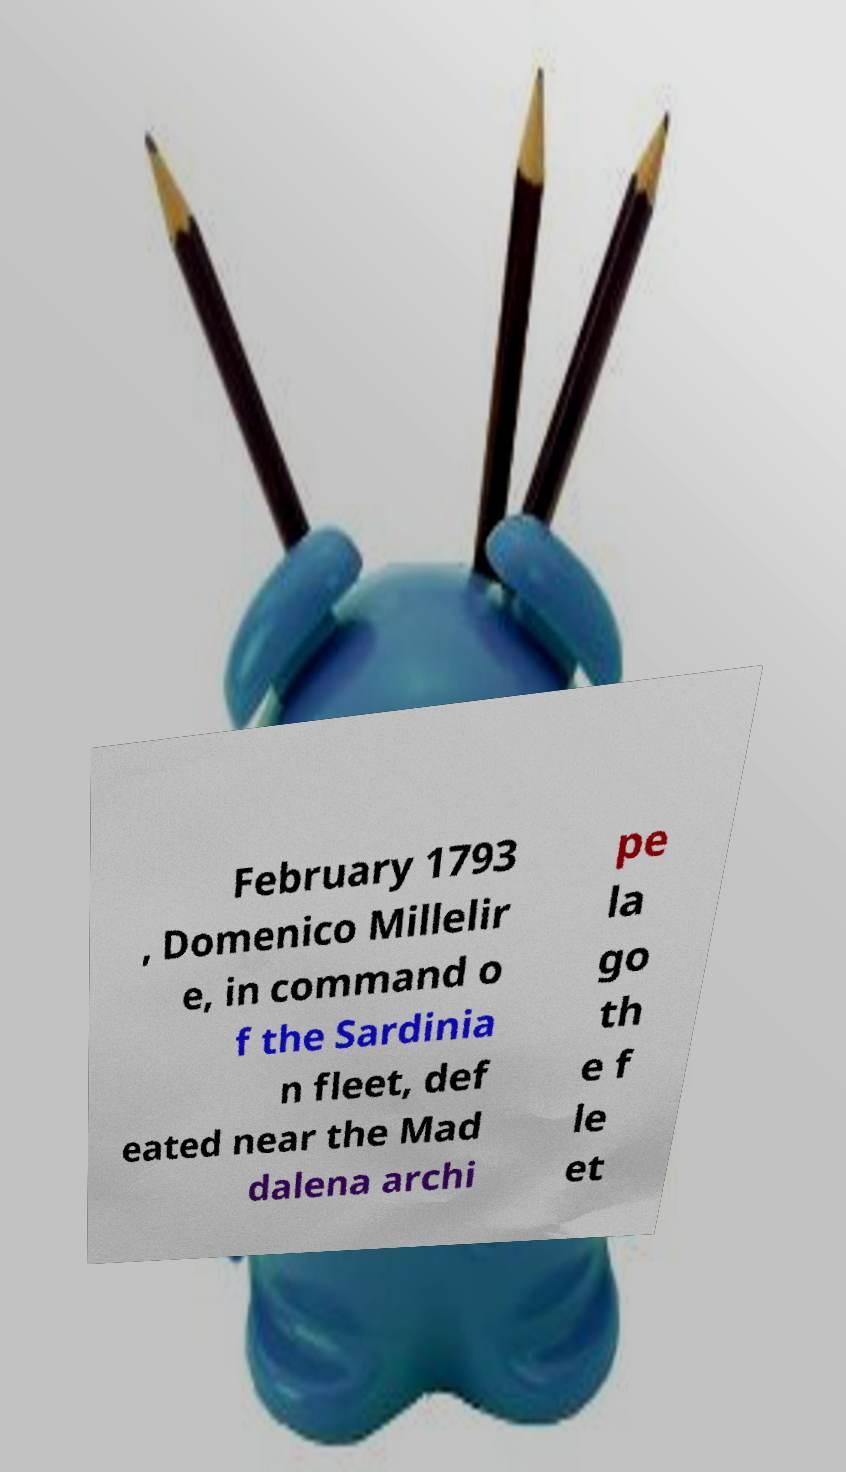Please identify and transcribe the text found in this image. February 1793 , Domenico Millelir e, in command o f the Sardinia n fleet, def eated near the Mad dalena archi pe la go th e f le et 